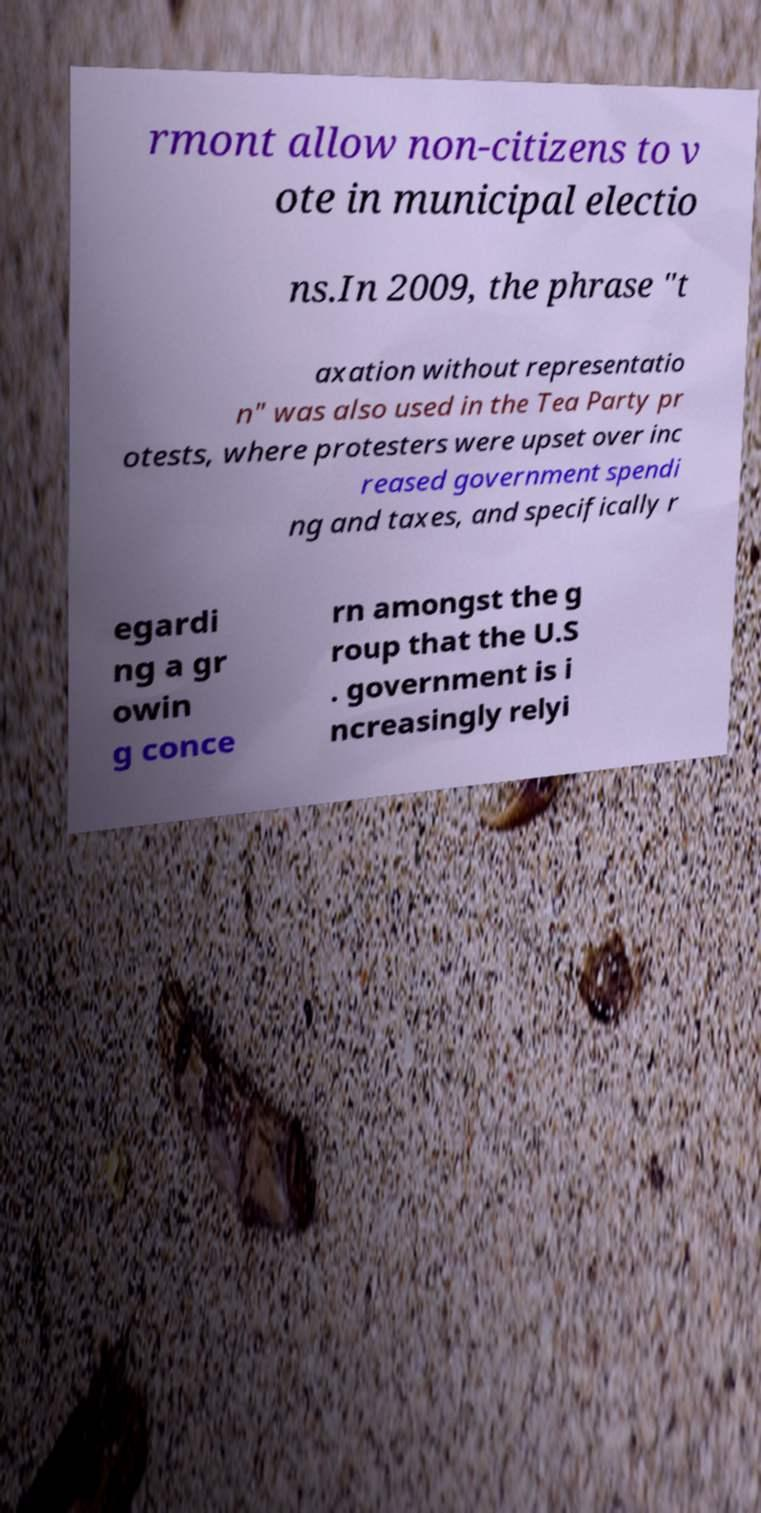Can you read and provide the text displayed in the image?This photo seems to have some interesting text. Can you extract and type it out for me? rmont allow non-citizens to v ote in municipal electio ns.In 2009, the phrase "t axation without representatio n" was also used in the Tea Party pr otests, where protesters were upset over inc reased government spendi ng and taxes, and specifically r egardi ng a gr owin g conce rn amongst the g roup that the U.S . government is i ncreasingly relyi 